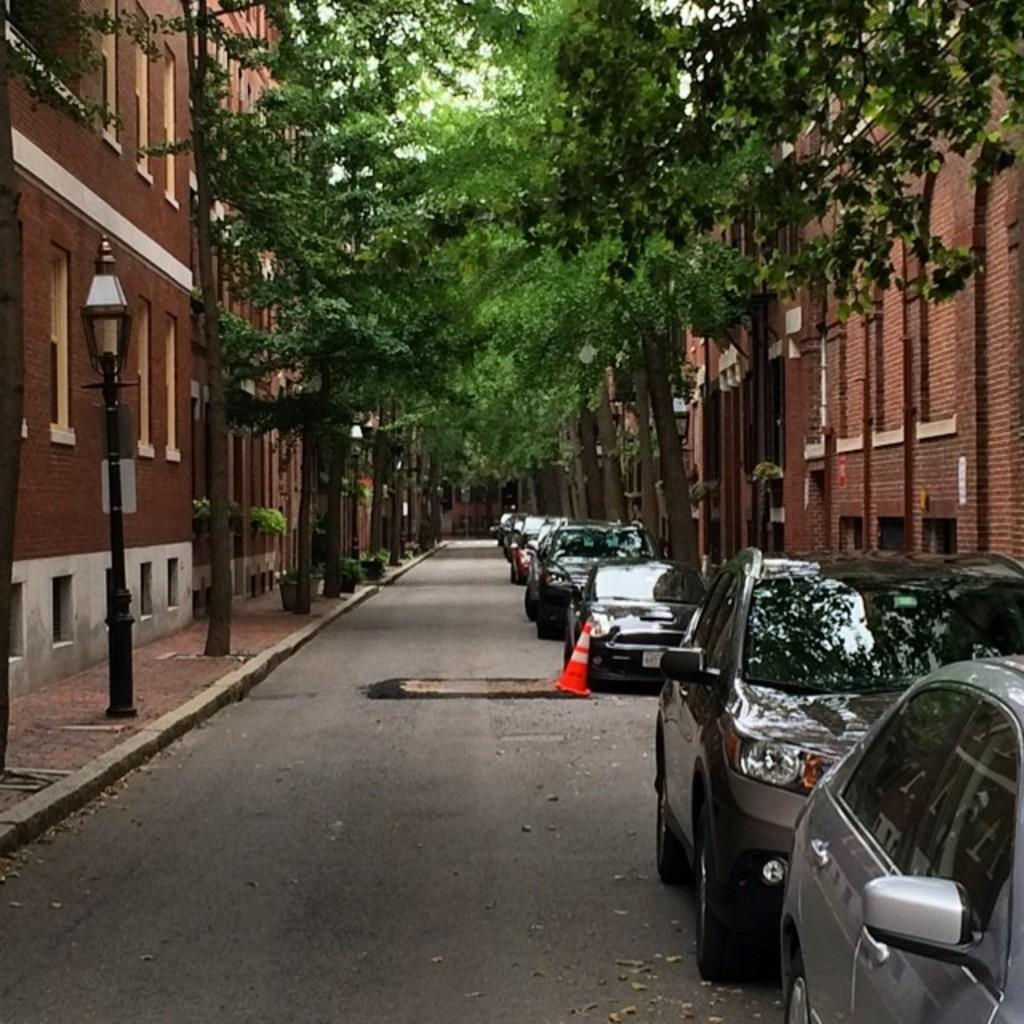What type of location is depicted in the image? There is a street in the image. What can be seen on the right side of the road? There are cars parked on the right side of the road. What structures are visible in the image? There are buildings visible in the image. What type of vegetation is present in the image? There are trees present in the image. What type of behavior can be observed in the earth in the image? There is no earth present in the image, as it is a street scene with buildings, trees, and parked cars. 